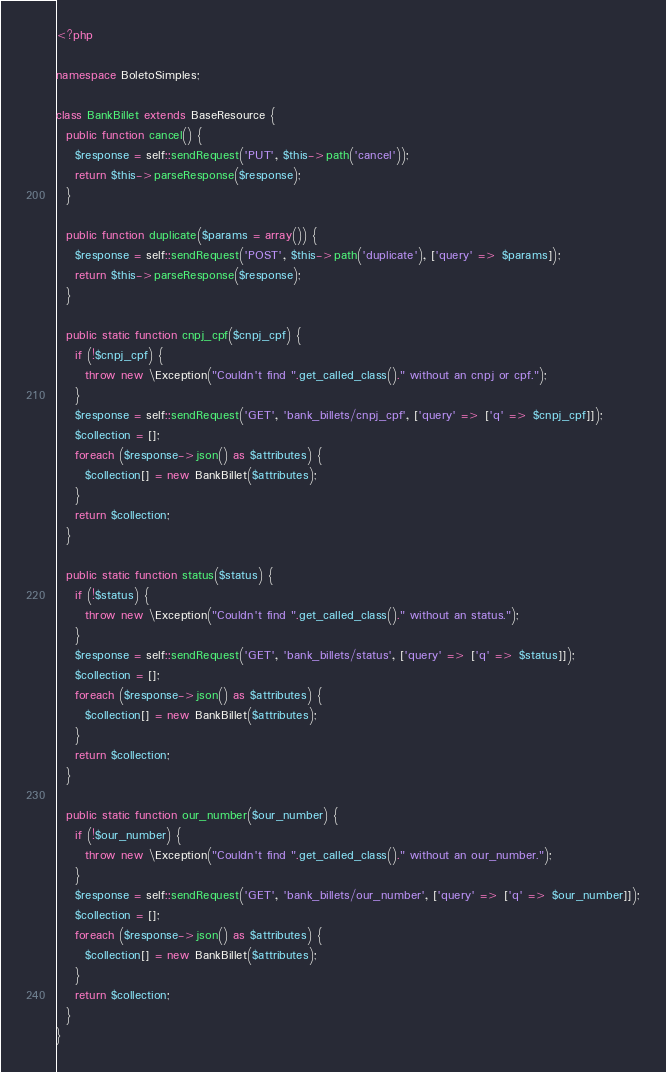<code> <loc_0><loc_0><loc_500><loc_500><_PHP_><?php

namespace BoletoSimples;

class BankBillet extends BaseResource {
  public function cancel() {
    $response = self::sendRequest('PUT', $this->path('cancel'));
    return $this->parseResponse($response);
  }

  public function duplicate($params = array()) {
    $response = self::sendRequest('POST', $this->path('duplicate'), ['query' => $params]);
    return $this->parseResponse($response);
  }

  public static function cnpj_cpf($cnpj_cpf) {
    if (!$cnpj_cpf) {
      throw new \Exception("Couldn't find ".get_called_class()." without an cnpj or cpf.");
    }
    $response = self::sendRequest('GET', 'bank_billets/cnpj_cpf', ['query' => ['q' => $cnpj_cpf]]);
    $collection = [];
    foreach ($response->json() as $attributes) {
      $collection[] = new BankBillet($attributes);
    }
    return $collection;
  }

  public static function status($status) {
    if (!$status) {
      throw new \Exception("Couldn't find ".get_called_class()." without an status.");
    }
    $response = self::sendRequest('GET', 'bank_billets/status', ['query' => ['q' => $status]]);
    $collection = [];
    foreach ($response->json() as $attributes) {
      $collection[] = new BankBillet($attributes);
    }
    return $collection;
  }

  public static function our_number($our_number) {
    if (!$our_number) {
      throw new \Exception("Couldn't find ".get_called_class()." without an our_number.");
    }
    $response = self::sendRequest('GET', 'bank_billets/our_number', ['query' => ['q' => $our_number]]);
    $collection = [];
    foreach ($response->json() as $attributes) {
      $collection[] = new BankBillet($attributes);
    }
    return $collection;
  }
}</code> 